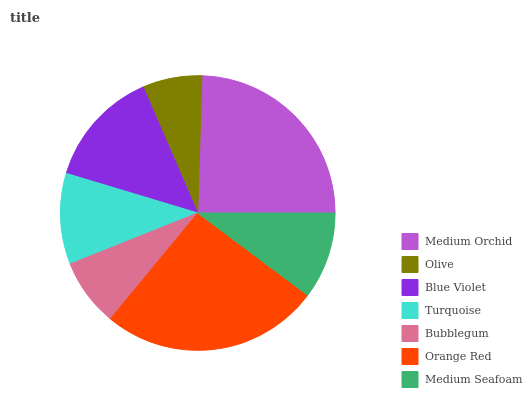Is Olive the minimum?
Answer yes or no. Yes. Is Orange Red the maximum?
Answer yes or no. Yes. Is Blue Violet the minimum?
Answer yes or no. No. Is Blue Violet the maximum?
Answer yes or no. No. Is Blue Violet greater than Olive?
Answer yes or no. Yes. Is Olive less than Blue Violet?
Answer yes or no. Yes. Is Olive greater than Blue Violet?
Answer yes or no. No. Is Blue Violet less than Olive?
Answer yes or no. No. Is Turquoise the high median?
Answer yes or no. Yes. Is Turquoise the low median?
Answer yes or no. Yes. Is Orange Red the high median?
Answer yes or no. No. Is Bubblegum the low median?
Answer yes or no. No. 